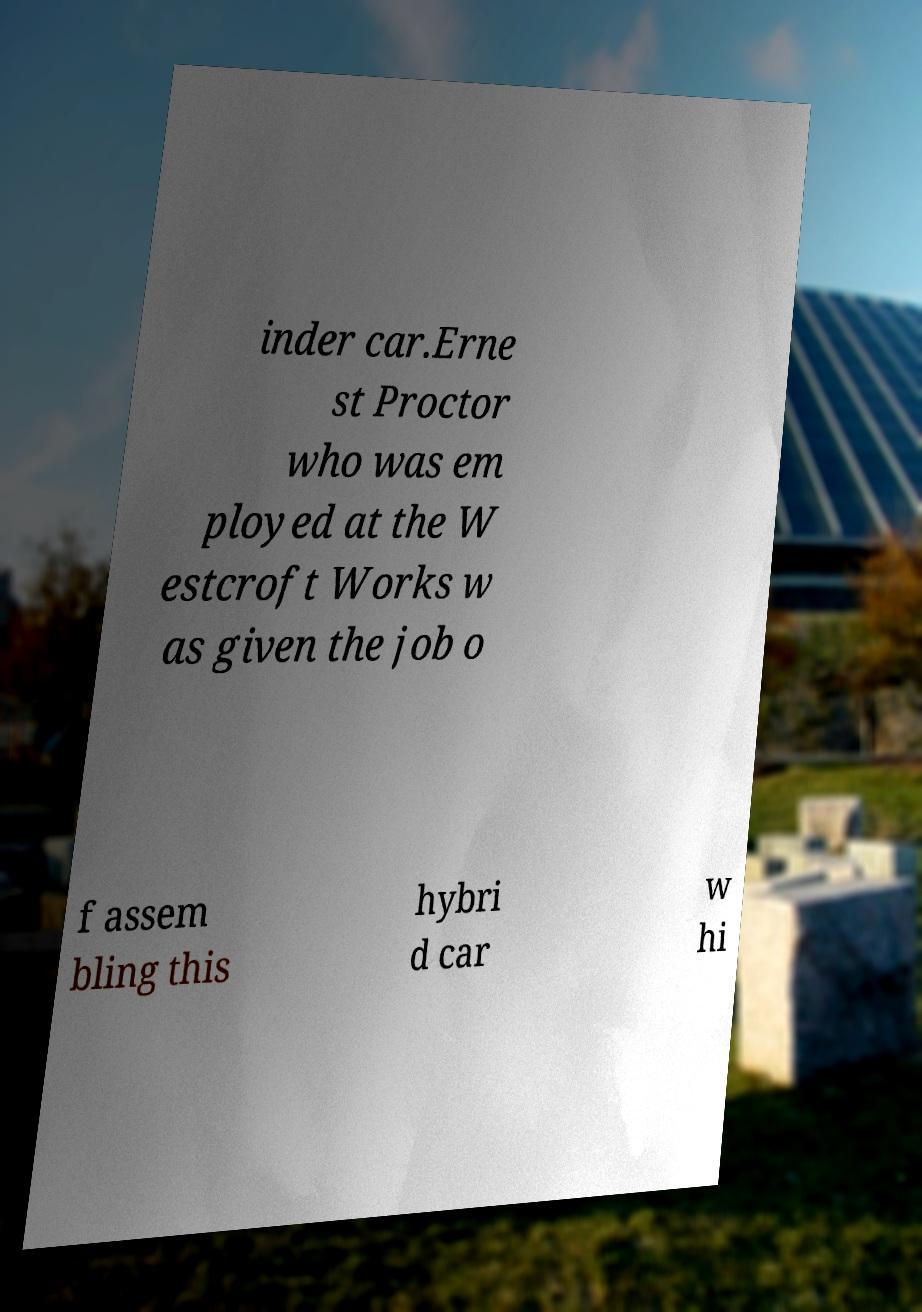Please identify and transcribe the text found in this image. inder car.Erne st Proctor who was em ployed at the W estcroft Works w as given the job o f assem bling this hybri d car w hi 